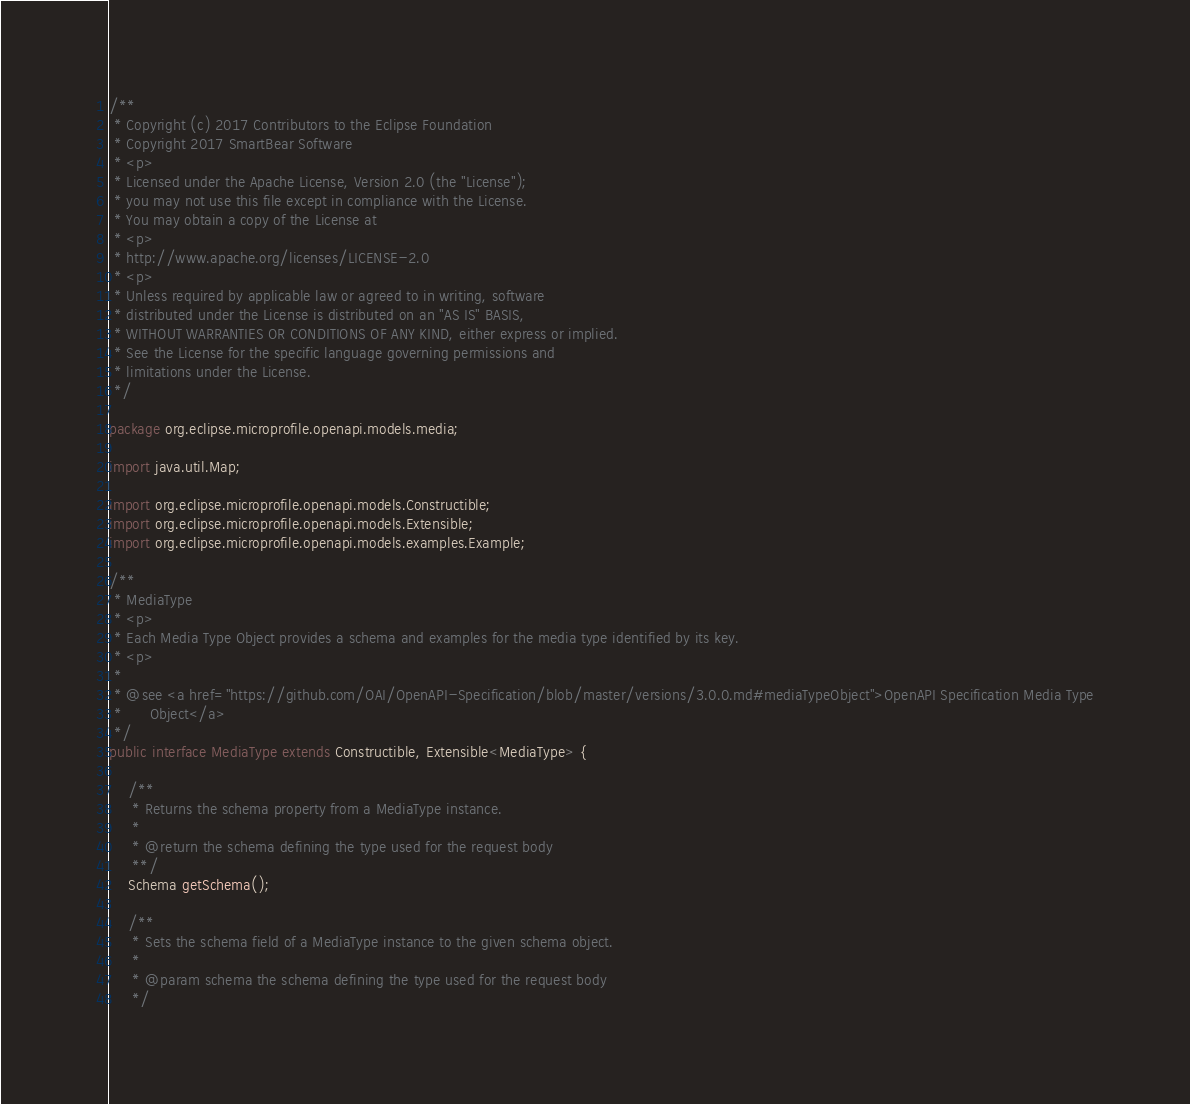<code> <loc_0><loc_0><loc_500><loc_500><_Java_>/**
 * Copyright (c) 2017 Contributors to the Eclipse Foundation
 * Copyright 2017 SmartBear Software
 * <p>
 * Licensed under the Apache License, Version 2.0 (the "License");
 * you may not use this file except in compliance with the License.
 * You may obtain a copy of the License at
 * <p>
 * http://www.apache.org/licenses/LICENSE-2.0
 * <p>
 * Unless required by applicable law or agreed to in writing, software
 * distributed under the License is distributed on an "AS IS" BASIS,
 * WITHOUT WARRANTIES OR CONDITIONS OF ANY KIND, either express or implied.
 * See the License for the specific language governing permissions and
 * limitations under the License.
 */

package org.eclipse.microprofile.openapi.models.media;

import java.util.Map;

import org.eclipse.microprofile.openapi.models.Constructible;
import org.eclipse.microprofile.openapi.models.Extensible;
import org.eclipse.microprofile.openapi.models.examples.Example;

/**
 * MediaType
 * <p>
 * Each Media Type Object provides a schema and examples for the media type identified by its key.
 * <p>
 * 
 * @see <a href="https://github.com/OAI/OpenAPI-Specification/blob/master/versions/3.0.0.md#mediaTypeObject">OpenAPI Specification Media Type
 *      Object</a>
 */
public interface MediaType extends Constructible, Extensible<MediaType> {

    /**
     * Returns the schema property from a MediaType instance.
     *
     * @return the schema defining the type used for the request body
     **/
    Schema getSchema();

    /**
     * Sets the schema field of a MediaType instance to the given schema object.
     *
     * @param schema the schema defining the type used for the request body
     */</code> 